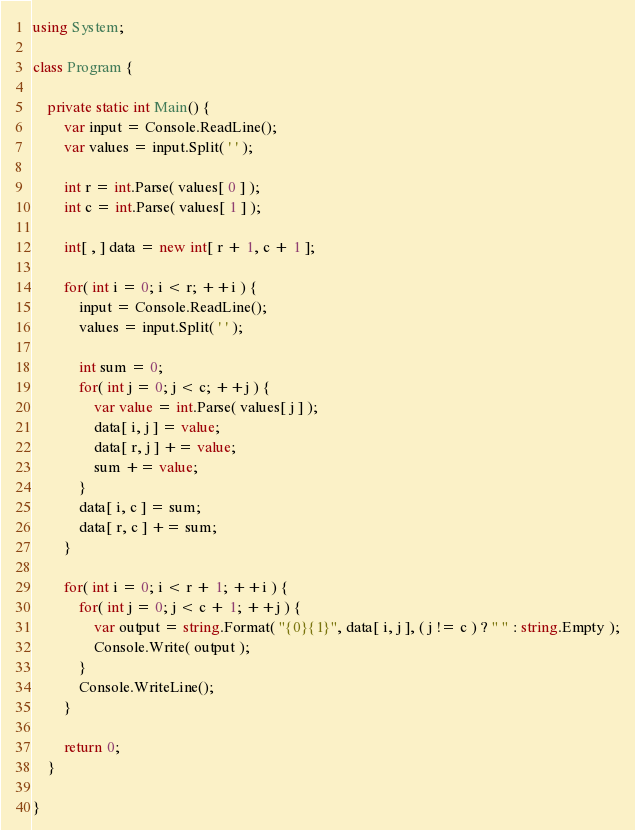Convert code to text. <code><loc_0><loc_0><loc_500><loc_500><_C#_>using System;

class Program {

    private static int Main() {
        var input = Console.ReadLine();
        var values = input.Split( ' ' );

        int r = int.Parse( values[ 0 ] );
        int c = int.Parse( values[ 1 ] );

        int[ , ] data = new int[ r + 1, c + 1 ];

        for( int i = 0; i < r; ++i ) {
            input = Console.ReadLine();
            values = input.Split( ' ' );

            int sum = 0;
            for( int j = 0; j < c; ++j ) {
                var value = int.Parse( values[ j ] );
                data[ i, j ] = value;
                data[ r, j ] += value;
                sum += value;
            }
            data[ i, c ] = sum;
            data[ r, c ] += sum;
        }

        for( int i = 0; i < r + 1; ++i ) {
            for( int j = 0; j < c + 1; ++j ) {
                var output = string.Format( "{0}{1}", data[ i, j ], ( j != c ) ? " " : string.Empty );
                Console.Write( output );
            }
            Console.WriteLine();
        }

        return 0;
    }

}</code> 